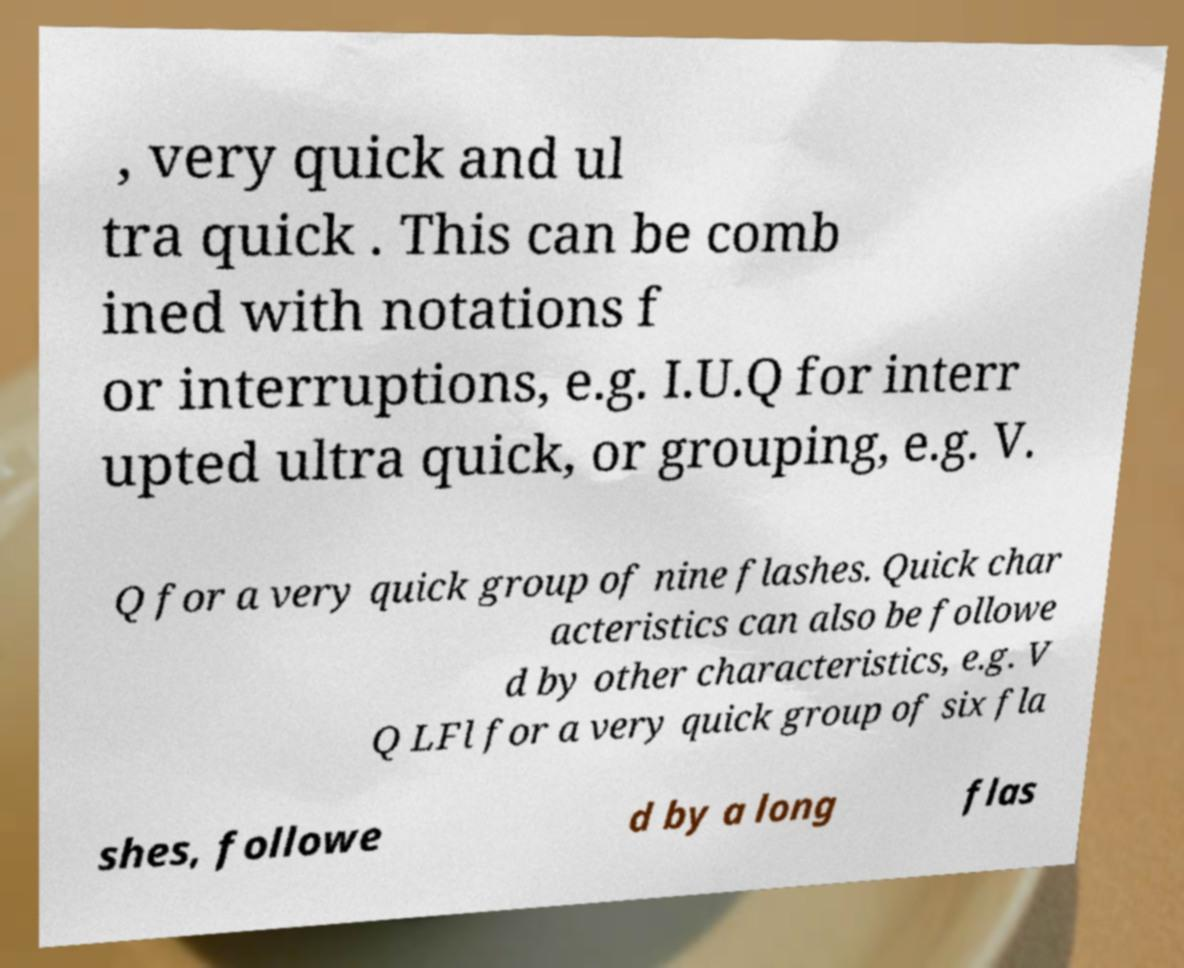Can you read and provide the text displayed in the image?This photo seems to have some interesting text. Can you extract and type it out for me? , very quick and ul tra quick . This can be comb ined with notations f or interruptions, e.g. I.U.Q for interr upted ultra quick, or grouping, e.g. V. Q for a very quick group of nine flashes. Quick char acteristics can also be followe d by other characteristics, e.g. V Q LFl for a very quick group of six fla shes, followe d by a long flas 